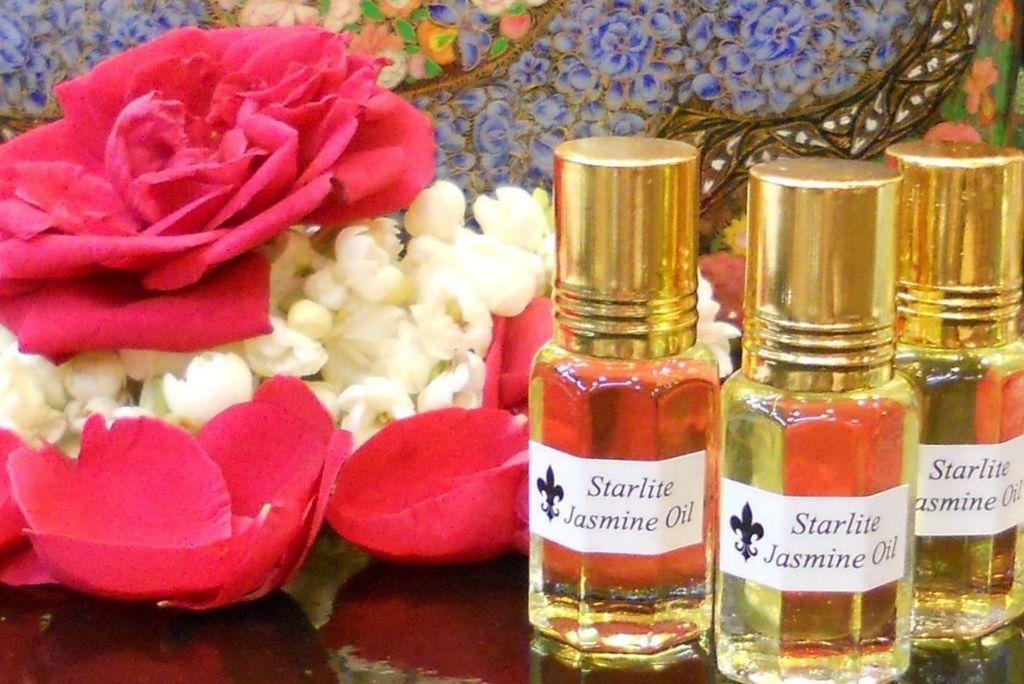<image>
Describe the image concisely. Three bottles of starlite jasmine oil with gold tops 